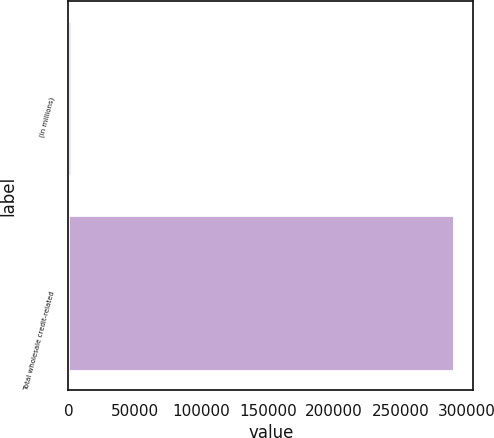Convert chart to OTSL. <chart><loc_0><loc_0><loc_500><loc_500><bar_chart><fcel>(in millions)<fcel>Total wholesale credit-related<nl><fcel>2007<fcel>290212<nl></chart> 